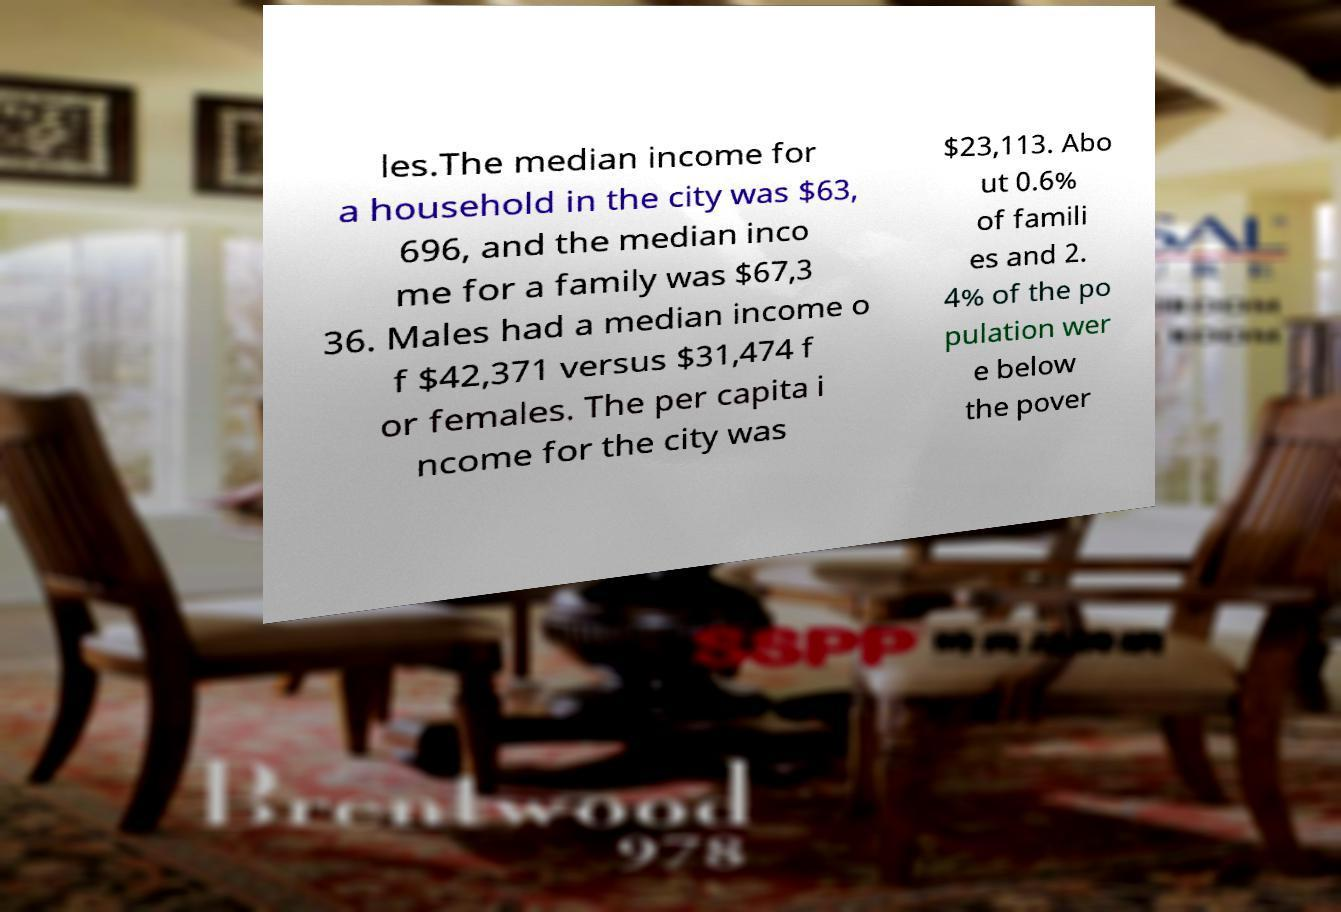Could you extract and type out the text from this image? les.The median income for a household in the city was $63, 696, and the median inco me for a family was $67,3 36. Males had a median income o f $42,371 versus $31,474 f or females. The per capita i ncome for the city was $23,113. Abo ut 0.6% of famili es and 2. 4% of the po pulation wer e below the pover 